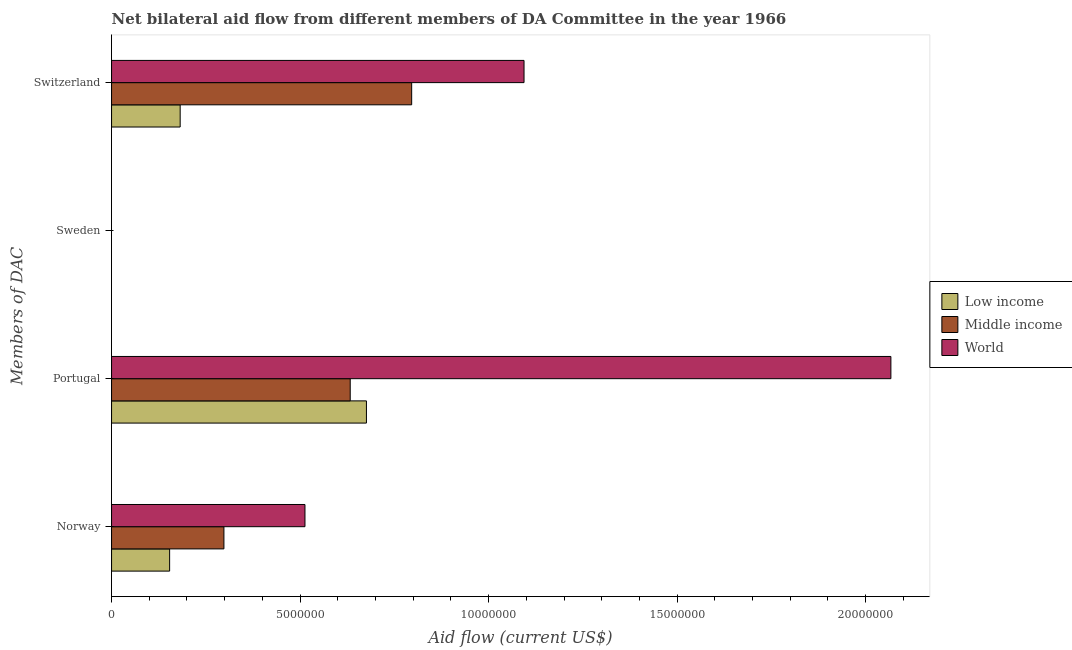How many different coloured bars are there?
Give a very brief answer. 3. What is the amount of aid given by portugal in Middle income?
Offer a very short reply. 6.33e+06. Across all countries, what is the maximum amount of aid given by portugal?
Keep it short and to the point. 2.07e+07. What is the total amount of aid given by portugal in the graph?
Ensure brevity in your answer.  3.38e+07. What is the difference between the amount of aid given by norway in World and that in Middle income?
Your answer should be compact. 2.15e+06. What is the difference between the amount of aid given by switzerland in Middle income and the amount of aid given by sweden in World?
Make the answer very short. 7.96e+06. What is the average amount of aid given by portugal per country?
Offer a very short reply. 1.13e+07. What is the difference between the amount of aid given by norway and amount of aid given by portugal in Middle income?
Give a very brief answer. -3.35e+06. In how many countries, is the amount of aid given by switzerland greater than 5000000 US$?
Your answer should be compact. 2. What is the ratio of the amount of aid given by switzerland in Middle income to that in World?
Provide a succinct answer. 0.73. Is the difference between the amount of aid given by portugal in Low income and Middle income greater than the difference between the amount of aid given by norway in Low income and Middle income?
Provide a short and direct response. Yes. What is the difference between the highest and the second highest amount of aid given by portugal?
Make the answer very short. 1.39e+07. What is the difference between the highest and the lowest amount of aid given by norway?
Your response must be concise. 3.59e+06. In how many countries, is the amount of aid given by sweden greater than the average amount of aid given by sweden taken over all countries?
Keep it short and to the point. 0. Is the sum of the amount of aid given by norway in Middle income and Low income greater than the maximum amount of aid given by switzerland across all countries?
Offer a very short reply. No. Are all the bars in the graph horizontal?
Provide a short and direct response. Yes. Are the values on the major ticks of X-axis written in scientific E-notation?
Provide a succinct answer. No. Where does the legend appear in the graph?
Ensure brevity in your answer.  Center right. How many legend labels are there?
Keep it short and to the point. 3. What is the title of the graph?
Give a very brief answer. Net bilateral aid flow from different members of DA Committee in the year 1966. What is the label or title of the Y-axis?
Your answer should be compact. Members of DAC. What is the Aid flow (current US$) in Low income in Norway?
Provide a short and direct response. 1.54e+06. What is the Aid flow (current US$) in Middle income in Norway?
Keep it short and to the point. 2.98e+06. What is the Aid flow (current US$) in World in Norway?
Make the answer very short. 5.13e+06. What is the Aid flow (current US$) of Low income in Portugal?
Provide a short and direct response. 6.76e+06. What is the Aid flow (current US$) of Middle income in Portugal?
Give a very brief answer. 6.33e+06. What is the Aid flow (current US$) in World in Portugal?
Your answer should be compact. 2.07e+07. What is the Aid flow (current US$) in Low income in Sweden?
Provide a short and direct response. Nan. What is the Aid flow (current US$) of Middle income in Sweden?
Provide a succinct answer. Nan. What is the Aid flow (current US$) of World in Sweden?
Give a very brief answer. Nan. What is the Aid flow (current US$) of Low income in Switzerland?
Ensure brevity in your answer.  1.82e+06. What is the Aid flow (current US$) of Middle income in Switzerland?
Make the answer very short. 7.96e+06. What is the Aid flow (current US$) of World in Switzerland?
Keep it short and to the point. 1.09e+07. Across all Members of DAC, what is the maximum Aid flow (current US$) in Low income?
Offer a terse response. 6.76e+06. Across all Members of DAC, what is the maximum Aid flow (current US$) of Middle income?
Your answer should be compact. 7.96e+06. Across all Members of DAC, what is the maximum Aid flow (current US$) in World?
Your response must be concise. 2.07e+07. Across all Members of DAC, what is the minimum Aid flow (current US$) in Low income?
Provide a short and direct response. 1.54e+06. Across all Members of DAC, what is the minimum Aid flow (current US$) in Middle income?
Keep it short and to the point. 2.98e+06. Across all Members of DAC, what is the minimum Aid flow (current US$) of World?
Give a very brief answer. 5.13e+06. What is the total Aid flow (current US$) in Low income in the graph?
Ensure brevity in your answer.  1.01e+07. What is the total Aid flow (current US$) of Middle income in the graph?
Offer a terse response. 1.73e+07. What is the total Aid flow (current US$) of World in the graph?
Your answer should be very brief. 3.67e+07. What is the difference between the Aid flow (current US$) in Low income in Norway and that in Portugal?
Offer a very short reply. -5.22e+06. What is the difference between the Aid flow (current US$) of Middle income in Norway and that in Portugal?
Offer a very short reply. -3.35e+06. What is the difference between the Aid flow (current US$) in World in Norway and that in Portugal?
Keep it short and to the point. -1.55e+07. What is the difference between the Aid flow (current US$) in Low income in Norway and that in Sweden?
Provide a succinct answer. Nan. What is the difference between the Aid flow (current US$) in Middle income in Norway and that in Sweden?
Your answer should be very brief. Nan. What is the difference between the Aid flow (current US$) in World in Norway and that in Sweden?
Make the answer very short. Nan. What is the difference between the Aid flow (current US$) in Low income in Norway and that in Switzerland?
Your answer should be compact. -2.80e+05. What is the difference between the Aid flow (current US$) of Middle income in Norway and that in Switzerland?
Ensure brevity in your answer.  -4.98e+06. What is the difference between the Aid flow (current US$) of World in Norway and that in Switzerland?
Ensure brevity in your answer.  -5.81e+06. What is the difference between the Aid flow (current US$) of Low income in Portugal and that in Sweden?
Ensure brevity in your answer.  Nan. What is the difference between the Aid flow (current US$) of Middle income in Portugal and that in Sweden?
Your response must be concise. Nan. What is the difference between the Aid flow (current US$) in World in Portugal and that in Sweden?
Your response must be concise. Nan. What is the difference between the Aid flow (current US$) in Low income in Portugal and that in Switzerland?
Give a very brief answer. 4.94e+06. What is the difference between the Aid flow (current US$) in Middle income in Portugal and that in Switzerland?
Make the answer very short. -1.63e+06. What is the difference between the Aid flow (current US$) of World in Portugal and that in Switzerland?
Provide a succinct answer. 9.73e+06. What is the difference between the Aid flow (current US$) in Low income in Sweden and that in Switzerland?
Provide a succinct answer. Nan. What is the difference between the Aid flow (current US$) in Middle income in Sweden and that in Switzerland?
Offer a very short reply. Nan. What is the difference between the Aid flow (current US$) in World in Sweden and that in Switzerland?
Your answer should be very brief. Nan. What is the difference between the Aid flow (current US$) of Low income in Norway and the Aid flow (current US$) of Middle income in Portugal?
Offer a very short reply. -4.79e+06. What is the difference between the Aid flow (current US$) of Low income in Norway and the Aid flow (current US$) of World in Portugal?
Your answer should be very brief. -1.91e+07. What is the difference between the Aid flow (current US$) in Middle income in Norway and the Aid flow (current US$) in World in Portugal?
Give a very brief answer. -1.77e+07. What is the difference between the Aid flow (current US$) in Low income in Norway and the Aid flow (current US$) in Middle income in Sweden?
Your answer should be very brief. Nan. What is the difference between the Aid flow (current US$) in Low income in Norway and the Aid flow (current US$) in World in Sweden?
Ensure brevity in your answer.  Nan. What is the difference between the Aid flow (current US$) of Middle income in Norway and the Aid flow (current US$) of World in Sweden?
Make the answer very short. Nan. What is the difference between the Aid flow (current US$) in Low income in Norway and the Aid flow (current US$) in Middle income in Switzerland?
Provide a succinct answer. -6.42e+06. What is the difference between the Aid flow (current US$) of Low income in Norway and the Aid flow (current US$) of World in Switzerland?
Provide a succinct answer. -9.40e+06. What is the difference between the Aid flow (current US$) of Middle income in Norway and the Aid flow (current US$) of World in Switzerland?
Your answer should be very brief. -7.96e+06. What is the difference between the Aid flow (current US$) in Low income in Portugal and the Aid flow (current US$) in Middle income in Sweden?
Provide a short and direct response. Nan. What is the difference between the Aid flow (current US$) in Low income in Portugal and the Aid flow (current US$) in World in Sweden?
Provide a short and direct response. Nan. What is the difference between the Aid flow (current US$) of Middle income in Portugal and the Aid flow (current US$) of World in Sweden?
Provide a short and direct response. Nan. What is the difference between the Aid flow (current US$) in Low income in Portugal and the Aid flow (current US$) in Middle income in Switzerland?
Your response must be concise. -1.20e+06. What is the difference between the Aid flow (current US$) in Low income in Portugal and the Aid flow (current US$) in World in Switzerland?
Offer a very short reply. -4.18e+06. What is the difference between the Aid flow (current US$) in Middle income in Portugal and the Aid flow (current US$) in World in Switzerland?
Give a very brief answer. -4.61e+06. What is the difference between the Aid flow (current US$) in Low income in Sweden and the Aid flow (current US$) in Middle income in Switzerland?
Keep it short and to the point. Nan. What is the difference between the Aid flow (current US$) of Low income in Sweden and the Aid flow (current US$) of World in Switzerland?
Provide a short and direct response. Nan. What is the difference between the Aid flow (current US$) in Middle income in Sweden and the Aid flow (current US$) in World in Switzerland?
Offer a terse response. Nan. What is the average Aid flow (current US$) of Low income per Members of DAC?
Your answer should be very brief. 2.53e+06. What is the average Aid flow (current US$) in Middle income per Members of DAC?
Your answer should be compact. 4.32e+06. What is the average Aid flow (current US$) in World per Members of DAC?
Your answer should be very brief. 9.18e+06. What is the difference between the Aid flow (current US$) of Low income and Aid flow (current US$) of Middle income in Norway?
Offer a very short reply. -1.44e+06. What is the difference between the Aid flow (current US$) in Low income and Aid flow (current US$) in World in Norway?
Offer a terse response. -3.59e+06. What is the difference between the Aid flow (current US$) of Middle income and Aid flow (current US$) of World in Norway?
Your answer should be compact. -2.15e+06. What is the difference between the Aid flow (current US$) in Low income and Aid flow (current US$) in Middle income in Portugal?
Offer a very short reply. 4.30e+05. What is the difference between the Aid flow (current US$) in Low income and Aid flow (current US$) in World in Portugal?
Provide a short and direct response. -1.39e+07. What is the difference between the Aid flow (current US$) in Middle income and Aid flow (current US$) in World in Portugal?
Offer a very short reply. -1.43e+07. What is the difference between the Aid flow (current US$) in Low income and Aid flow (current US$) in Middle income in Sweden?
Give a very brief answer. Nan. What is the difference between the Aid flow (current US$) of Low income and Aid flow (current US$) of World in Sweden?
Offer a terse response. Nan. What is the difference between the Aid flow (current US$) in Middle income and Aid flow (current US$) in World in Sweden?
Ensure brevity in your answer.  Nan. What is the difference between the Aid flow (current US$) of Low income and Aid flow (current US$) of Middle income in Switzerland?
Keep it short and to the point. -6.14e+06. What is the difference between the Aid flow (current US$) of Low income and Aid flow (current US$) of World in Switzerland?
Your answer should be very brief. -9.12e+06. What is the difference between the Aid flow (current US$) of Middle income and Aid flow (current US$) of World in Switzerland?
Your answer should be very brief. -2.98e+06. What is the ratio of the Aid flow (current US$) in Low income in Norway to that in Portugal?
Your answer should be very brief. 0.23. What is the ratio of the Aid flow (current US$) in Middle income in Norway to that in Portugal?
Ensure brevity in your answer.  0.47. What is the ratio of the Aid flow (current US$) of World in Norway to that in Portugal?
Give a very brief answer. 0.25. What is the ratio of the Aid flow (current US$) of Low income in Norway to that in Sweden?
Offer a very short reply. Nan. What is the ratio of the Aid flow (current US$) of Middle income in Norway to that in Sweden?
Offer a very short reply. Nan. What is the ratio of the Aid flow (current US$) in World in Norway to that in Sweden?
Give a very brief answer. Nan. What is the ratio of the Aid flow (current US$) in Low income in Norway to that in Switzerland?
Make the answer very short. 0.85. What is the ratio of the Aid flow (current US$) in Middle income in Norway to that in Switzerland?
Give a very brief answer. 0.37. What is the ratio of the Aid flow (current US$) of World in Norway to that in Switzerland?
Keep it short and to the point. 0.47. What is the ratio of the Aid flow (current US$) of Low income in Portugal to that in Sweden?
Your answer should be very brief. Nan. What is the ratio of the Aid flow (current US$) of Middle income in Portugal to that in Sweden?
Offer a terse response. Nan. What is the ratio of the Aid flow (current US$) in World in Portugal to that in Sweden?
Ensure brevity in your answer.  Nan. What is the ratio of the Aid flow (current US$) of Low income in Portugal to that in Switzerland?
Give a very brief answer. 3.71. What is the ratio of the Aid flow (current US$) of Middle income in Portugal to that in Switzerland?
Keep it short and to the point. 0.8. What is the ratio of the Aid flow (current US$) of World in Portugal to that in Switzerland?
Offer a very short reply. 1.89. What is the ratio of the Aid flow (current US$) in Low income in Sweden to that in Switzerland?
Make the answer very short. Nan. What is the ratio of the Aid flow (current US$) of Middle income in Sweden to that in Switzerland?
Ensure brevity in your answer.  Nan. What is the ratio of the Aid flow (current US$) of World in Sweden to that in Switzerland?
Your response must be concise. Nan. What is the difference between the highest and the second highest Aid flow (current US$) in Low income?
Give a very brief answer. 4.94e+06. What is the difference between the highest and the second highest Aid flow (current US$) of Middle income?
Provide a succinct answer. 1.63e+06. What is the difference between the highest and the second highest Aid flow (current US$) of World?
Offer a terse response. 9.73e+06. What is the difference between the highest and the lowest Aid flow (current US$) in Low income?
Provide a short and direct response. 5.22e+06. What is the difference between the highest and the lowest Aid flow (current US$) in Middle income?
Provide a succinct answer. 4.98e+06. What is the difference between the highest and the lowest Aid flow (current US$) of World?
Give a very brief answer. 1.55e+07. 